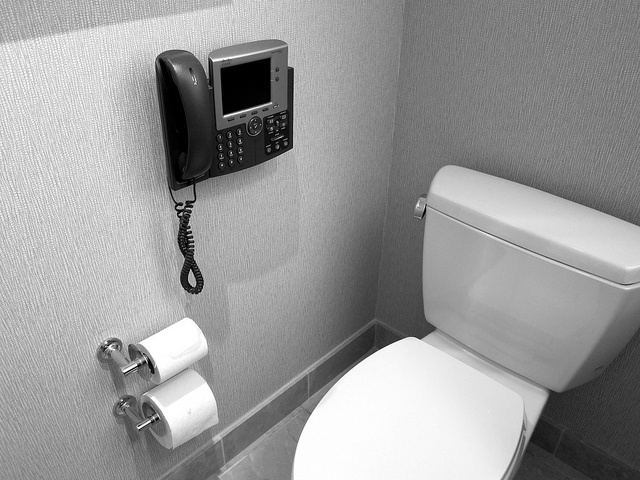Describe the objects in this image and their specific colors. I can see a toilet in lightgray, white, darkgray, gray, and black tones in this image. 